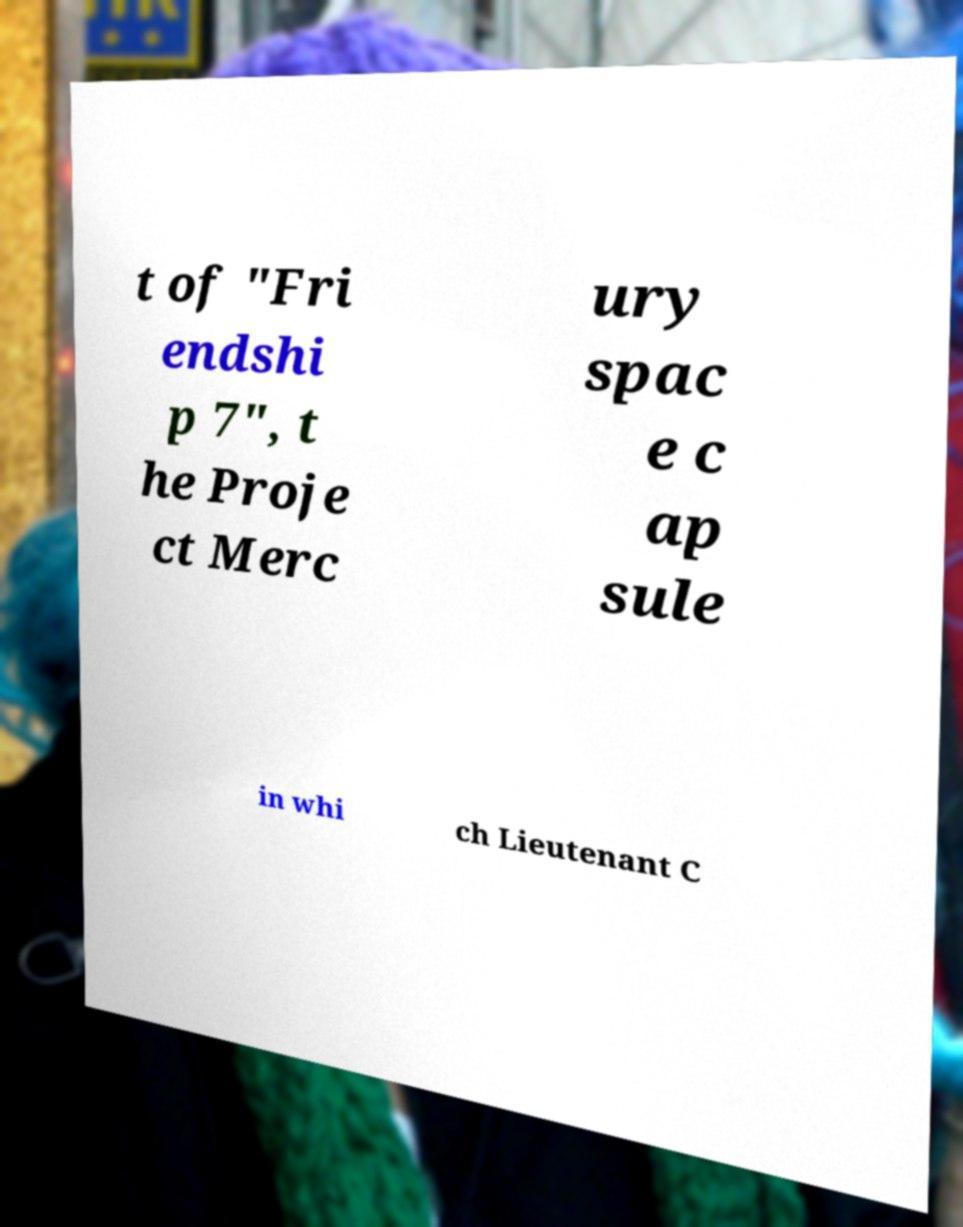Could you assist in decoding the text presented in this image and type it out clearly? t of "Fri endshi p 7", t he Proje ct Merc ury spac e c ap sule in whi ch Lieutenant C 